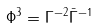<formula> <loc_0><loc_0><loc_500><loc_500>\Phi ^ { 3 } = \Gamma ^ { - 2 } \bar { \Gamma } ^ { - 1 }</formula> 